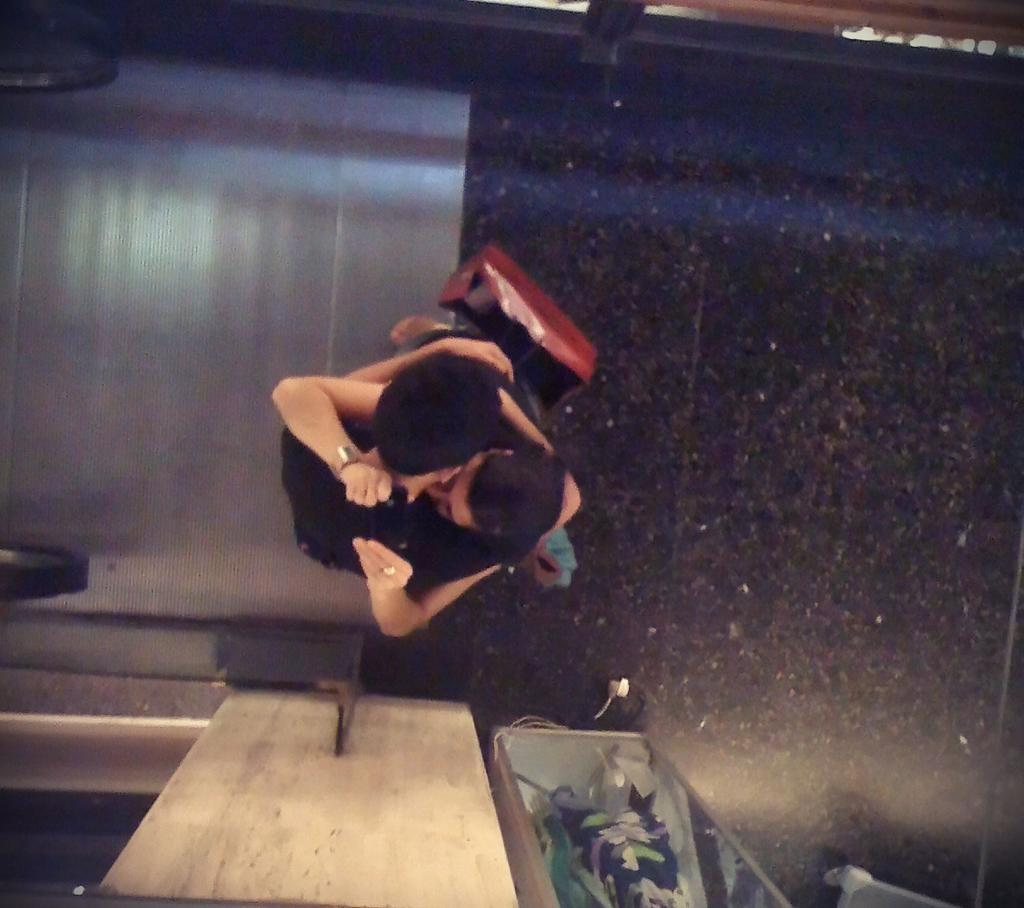What are the persons in the image doing? The persons in the image are hugging each other in the center of the image. What is located at the bottom of the image? There is a wall at the bottom of the image. Can you identify any objects in the image? Yes, there is a glass in the image. What shape is the soap in the image? There is no soap present in the image. What type of aunt can be seen in the image? There is no aunt present in the image. 